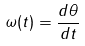Convert formula to latex. <formula><loc_0><loc_0><loc_500><loc_500>\omega ( t ) = \frac { d \theta } { d t }</formula> 